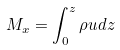Convert formula to latex. <formula><loc_0><loc_0><loc_500><loc_500>M _ { x } = \int _ { 0 } ^ { z } \rho u d z</formula> 